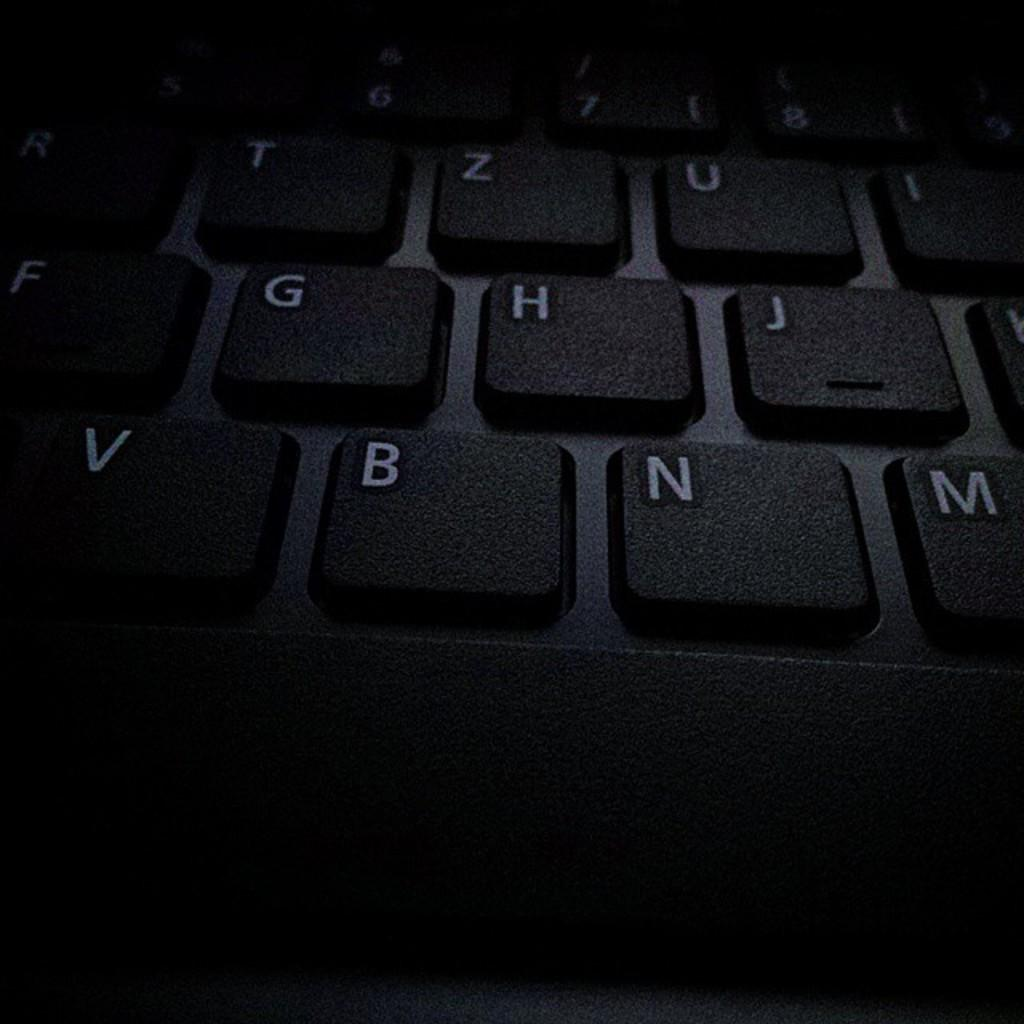<image>
Write a terse but informative summary of the picture. A close up of a black keyboard and on the last row the keys are V B N M. 